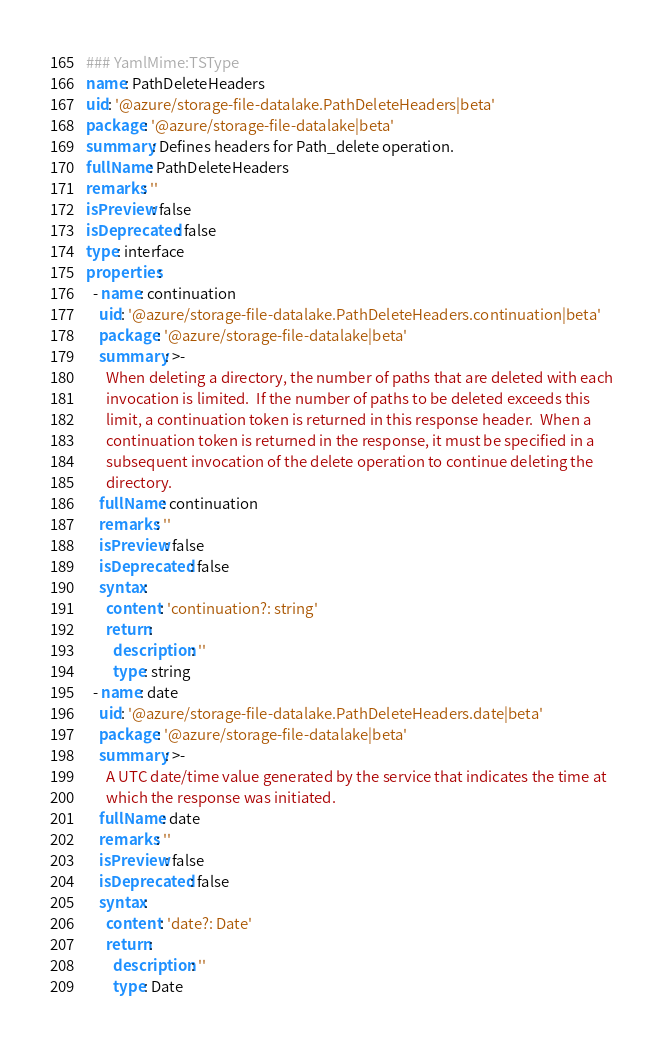Convert code to text. <code><loc_0><loc_0><loc_500><loc_500><_YAML_>### YamlMime:TSType
name: PathDeleteHeaders
uid: '@azure/storage-file-datalake.PathDeleteHeaders|beta'
package: '@azure/storage-file-datalake|beta'
summary: Defines headers for Path_delete operation.
fullName: PathDeleteHeaders
remarks: ''
isPreview: false
isDeprecated: false
type: interface
properties:
  - name: continuation
    uid: '@azure/storage-file-datalake.PathDeleteHeaders.continuation|beta'
    package: '@azure/storage-file-datalake|beta'
    summary: >-
      When deleting a directory, the number of paths that are deleted with each
      invocation is limited.  If the number of paths to be deleted exceeds this
      limit, a continuation token is returned in this response header.  When a
      continuation token is returned in the response, it must be specified in a
      subsequent invocation of the delete operation to continue deleting the
      directory.
    fullName: continuation
    remarks: ''
    isPreview: false
    isDeprecated: false
    syntax:
      content: 'continuation?: string'
      return:
        description: ''
        type: string
  - name: date
    uid: '@azure/storage-file-datalake.PathDeleteHeaders.date|beta'
    package: '@azure/storage-file-datalake|beta'
    summary: >-
      A UTC date/time value generated by the service that indicates the time at
      which the response was initiated.
    fullName: date
    remarks: ''
    isPreview: false
    isDeprecated: false
    syntax:
      content: 'date?: Date'
      return:
        description: ''
        type: Date</code> 